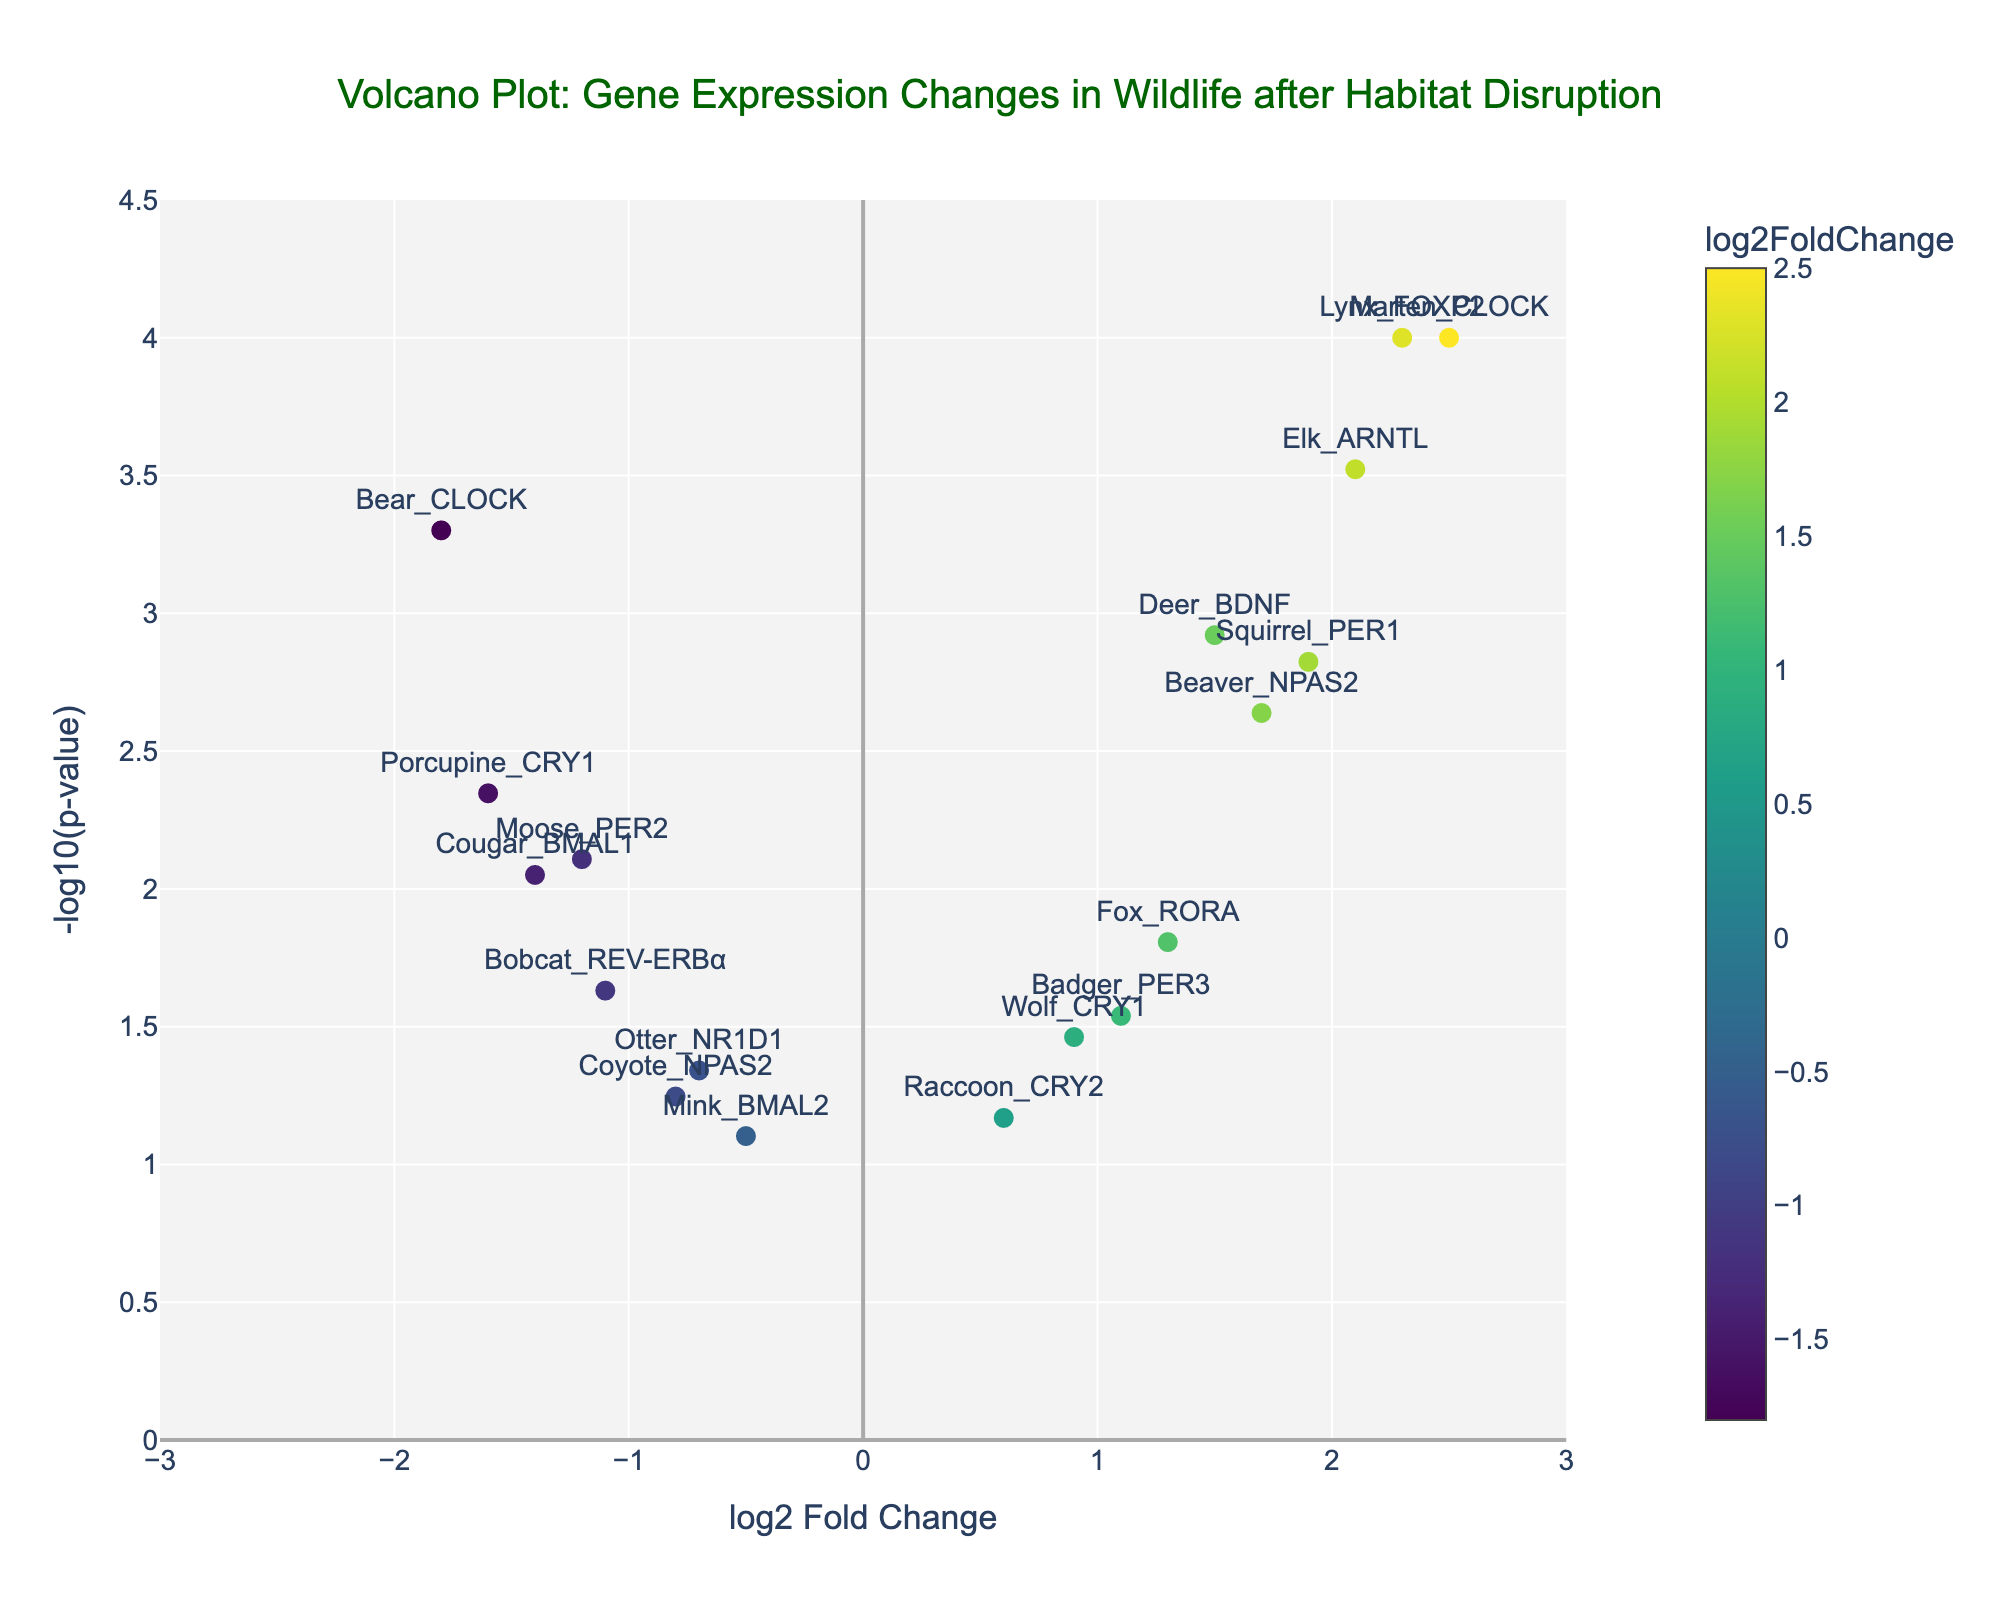What's the title of the plot? The title of the plot is located at the top center of the figure. It reads as "Volcano Plot: Gene Expression Changes in Wildlife after Habitat Disruption."
Answer: "Volcano Plot: Gene Expression Changes in Wildlife after Habitat Disruption" What is the -log10(p-value) of the gene 'Bear_CLOCK'? To find the -log10(p-value) for 'Bear_CLOCK', locate the data point with 'Bear_CLOCK' in the gene labels and read its y-coordinate value. The y-axis represents -log10(p-value).
Answer: 3.3010 Which gene has the highest log2 Fold Change? Look along the x-axis to find the point with the highest log2 Fold Change value. The gene label associated with this point is 'Marten_CLOCK'.
Answer: Marten_CLOCK What is the range of the x-axis? The range of the x-axis is specified in the figure settings. It is set from -3 to 3.
Answer: -3 to 3 Which gene has the smallest p-value? To find the smallest p-value, find the point with the highest y-coordinate (-log10(p-value)) on the plot. This is 'Lynx_FOXP2', which has the highest -log10(p-value).
Answer: Lynx_FOXP2 Compare the log2FoldChange of 'Elk_ARNTL' and 'Moose_PER2'. Which one is higher? Locate the positions of 'Elk_ARNTL' and 'Moose_PER2' on the x-axis. 'Elk_ARNTL' has a log2FoldChange of 2.1, which is higher than 'Moose_PER2' with a log2FoldChange of -1.2.
Answer: Elk_ARNTL What color scale is used for the markers, and what does it represent? The Viridis color scale is used for the markers. It represents the log2 Fold Change, where the color intensity increases with the magnitude of the log2 Fold Change.
Answer: Viridis color scale, log2 Fold Change How many genes have a log2 Fold Change greater than 0? Count the number of data points (genes) that are positioned to the right of the y-axis (log2 Fold Change > 0). There are 9 such genes.
Answer: 9 Which gene has a -log10(p-value) closest to 2? Locate the datapoint on the plot with a -log10(p-value) nearest to 2. The gene is 'Fox_RORA' with a -log10(p-value) of about 1.8062.
Answer: Fox_RORA 